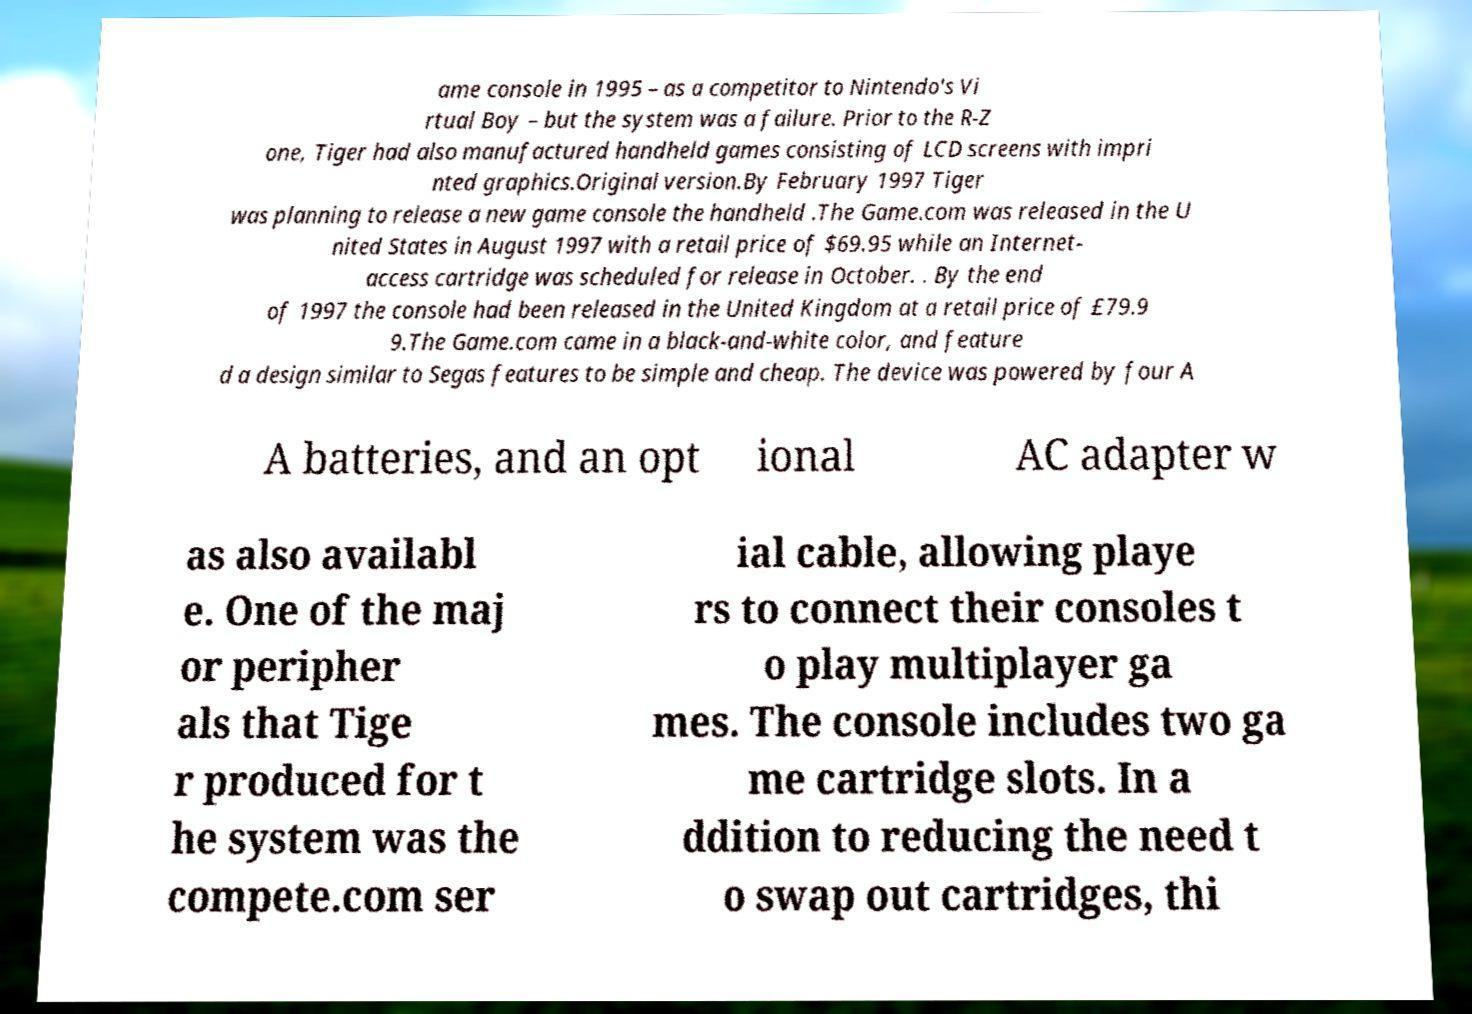What messages or text are displayed in this image? I need them in a readable, typed format. ame console in 1995 – as a competitor to Nintendo's Vi rtual Boy – but the system was a failure. Prior to the R-Z one, Tiger had also manufactured handheld games consisting of LCD screens with impri nted graphics.Original version.By February 1997 Tiger was planning to release a new game console the handheld .The Game.com was released in the U nited States in August 1997 with a retail price of $69.95 while an Internet- access cartridge was scheduled for release in October. . By the end of 1997 the console had been released in the United Kingdom at a retail price of £79.9 9.The Game.com came in a black-and-white color, and feature d a design similar to Segas features to be simple and cheap. The device was powered by four A A batteries, and an opt ional AC adapter w as also availabl e. One of the maj or peripher als that Tige r produced for t he system was the compete.com ser ial cable, allowing playe rs to connect their consoles t o play multiplayer ga mes. The console includes two ga me cartridge slots. In a ddition to reducing the need t o swap out cartridges, thi 